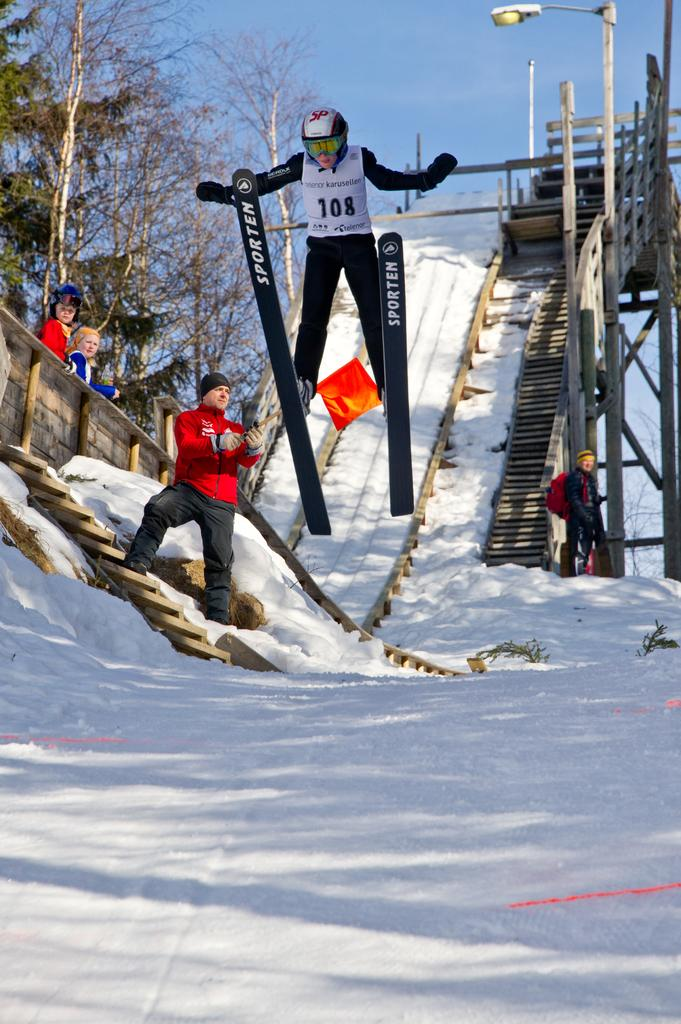What is the main subject of the image? There is a person in the image. What activity is the person engaged in? The person is on skiing boards. What safety gear is the person wearing? The person is wearing a helmet. What type of terrain is visible in the image? There is snow on the land in the image. What can be seen in the background of the image? There are trees and the sky visible in the background of the image. What is the creator's point of view when creating this image? There is no information provided about the creator or their point of view, so this question cannot be answered definitively. 